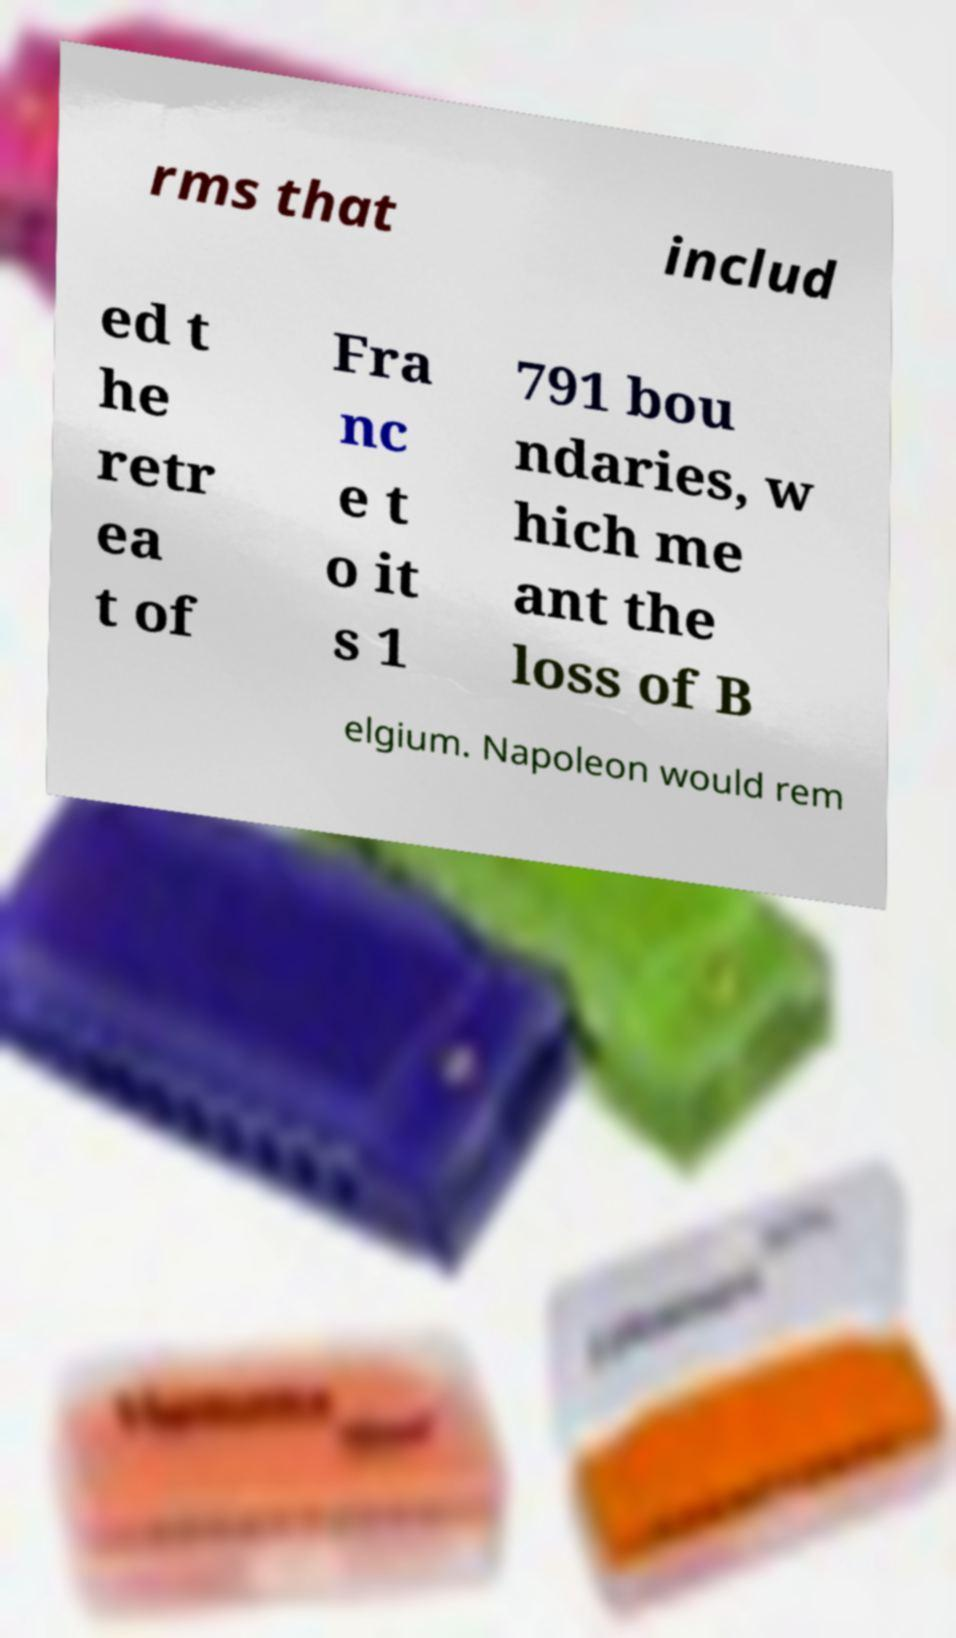Can you read and provide the text displayed in the image?This photo seems to have some interesting text. Can you extract and type it out for me? rms that includ ed t he retr ea t of Fra nc e t o it s 1 791 bou ndaries, w hich me ant the loss of B elgium. Napoleon would rem 